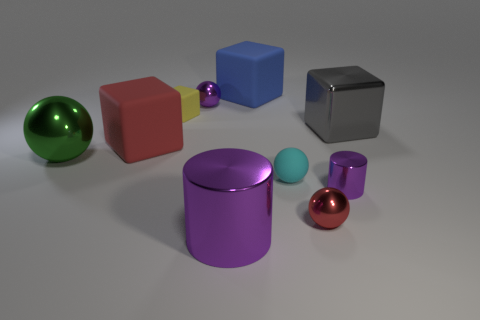Is the number of tiny cyan objects behind the yellow rubber object the same as the number of small yellow matte objects that are behind the red matte cube? No, the number of objects does not match. Among the items behind the yellow rubber object, there are two small cyan spheres, while only one small yellow matte object is positioned behind the red matte cube. 